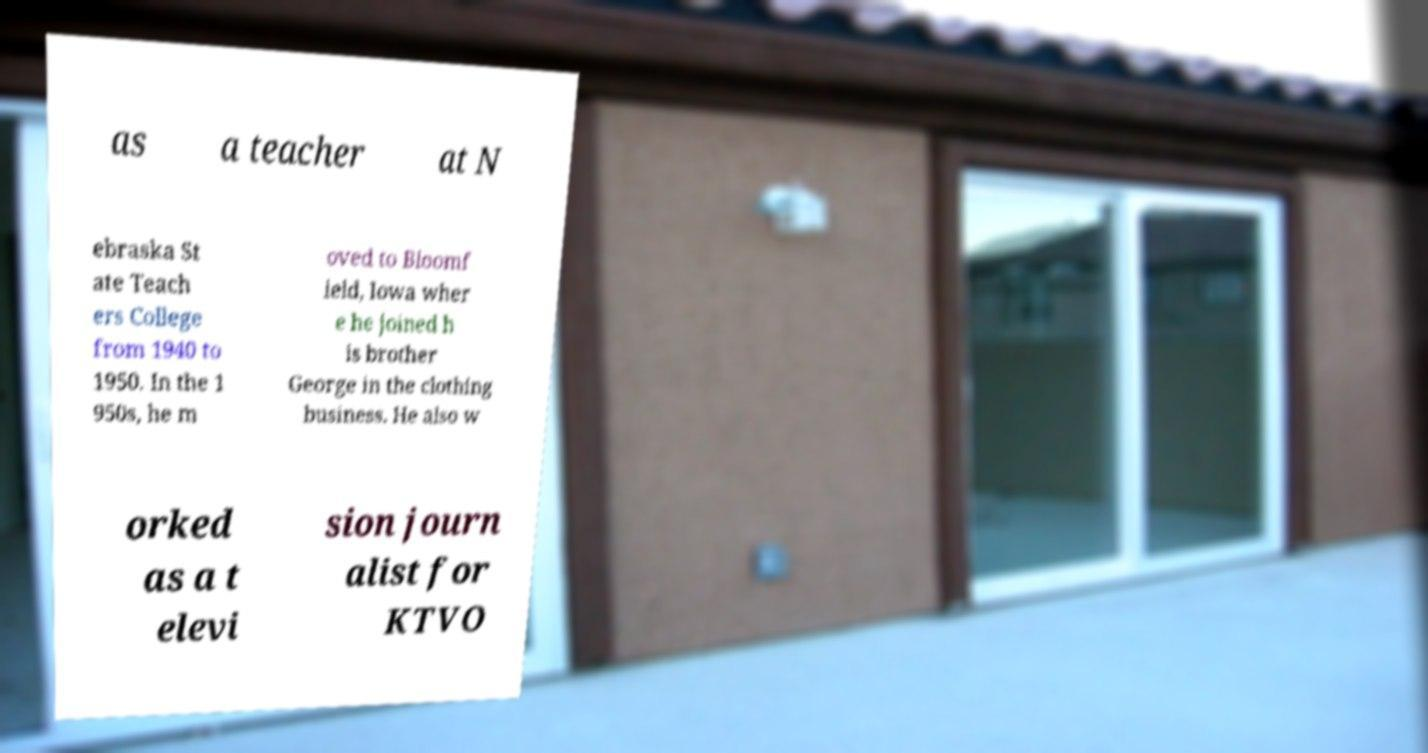Can you accurately transcribe the text from the provided image for me? as a teacher at N ebraska St ate Teach ers College from 1940 to 1950. In the 1 950s, he m oved to Bloomf ield, Iowa wher e he joined h is brother George in the clothing business. He also w orked as a t elevi sion journ alist for KTVO 